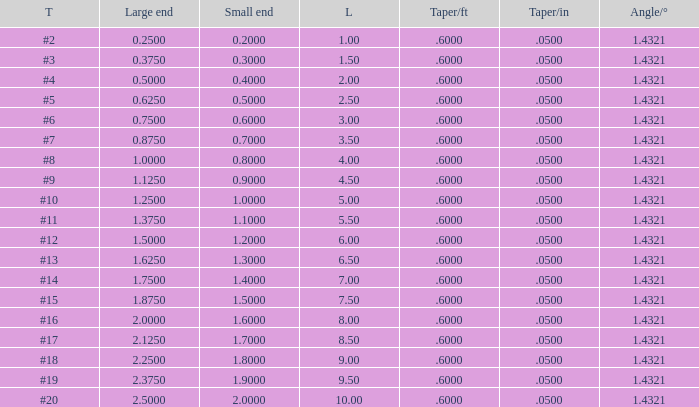Would you mind parsing the complete table? {'header': ['T', 'Large end', 'Small end', 'L', 'Taper/ft', 'Taper/in', 'Angle/°'], 'rows': [['#2', '0.2500', '0.2000', '1.00', '.6000', '.0500', '1.4321'], ['#3', '0.3750', '0.3000', '1.50', '.6000', '.0500', '1.4321'], ['#4', '0.5000', '0.4000', '2.00', '.6000', '.0500', '1.4321'], ['#5', '0.6250', '0.5000', '2.50', '.6000', '.0500', '1.4321'], ['#6', '0.7500', '0.6000', '3.00', '.6000', '.0500', '1.4321'], ['#7', '0.8750', '0.7000', '3.50', '.6000', '.0500', '1.4321'], ['#8', '1.0000', '0.8000', '4.00', '.6000', '.0500', '1.4321'], ['#9', '1.1250', '0.9000', '4.50', '.6000', '.0500', '1.4321'], ['#10', '1.2500', '1.0000', '5.00', '.6000', '.0500', '1.4321'], ['#11', '1.3750', '1.1000', '5.50', '.6000', '.0500', '1.4321'], ['#12', '1.5000', '1.2000', '6.00', '.6000', '.0500', '1.4321'], ['#13', '1.6250', '1.3000', '6.50', '.6000', '.0500', '1.4321'], ['#14', '1.7500', '1.4000', '7.00', '.6000', '.0500', '1.4321'], ['#15', '1.8750', '1.5000', '7.50', '.6000', '.0500', '1.4321'], ['#16', '2.0000', '1.6000', '8.00', '.6000', '.0500', '1.4321'], ['#17', '2.1250', '1.7000', '8.50', '.6000', '.0500', '1.4321'], ['#18', '2.2500', '1.8000', '9.00', '.6000', '.0500', '1.4321'], ['#19', '2.3750', '1.9000', '9.50', '.6000', '.0500', '1.4321'], ['#20', '2.5000', '2.0000', '10.00', '.6000', '.0500', '1.4321']]} Which Taper/ft that has a Large end smaller than 0.5, and a Taper of #2? 0.6. 